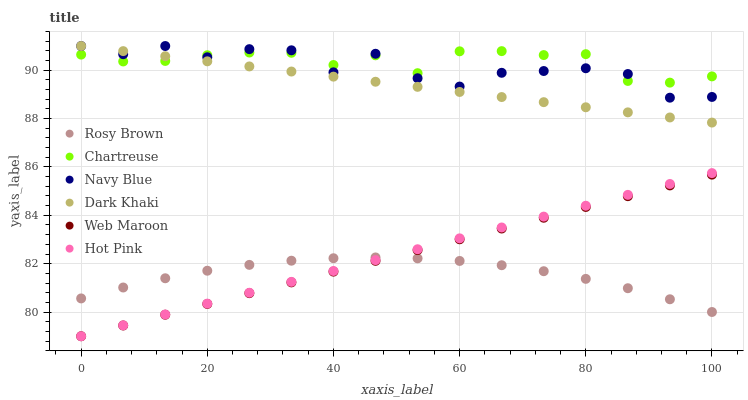Does Rosy Brown have the minimum area under the curve?
Answer yes or no. Yes. Does Chartreuse have the maximum area under the curve?
Answer yes or no. Yes. Does Navy Blue have the minimum area under the curve?
Answer yes or no. No. Does Navy Blue have the maximum area under the curve?
Answer yes or no. No. Is Dark Khaki the smoothest?
Answer yes or no. Yes. Is Navy Blue the roughest?
Answer yes or no. Yes. Is Rosy Brown the smoothest?
Answer yes or no. No. Is Rosy Brown the roughest?
Answer yes or no. No. Does Hot Pink have the lowest value?
Answer yes or no. Yes. Does Navy Blue have the lowest value?
Answer yes or no. No. Does Dark Khaki have the highest value?
Answer yes or no. Yes. Does Rosy Brown have the highest value?
Answer yes or no. No. Is Rosy Brown less than Navy Blue?
Answer yes or no. Yes. Is Navy Blue greater than Rosy Brown?
Answer yes or no. Yes. Does Dark Khaki intersect Chartreuse?
Answer yes or no. Yes. Is Dark Khaki less than Chartreuse?
Answer yes or no. No. Is Dark Khaki greater than Chartreuse?
Answer yes or no. No. Does Rosy Brown intersect Navy Blue?
Answer yes or no. No. 